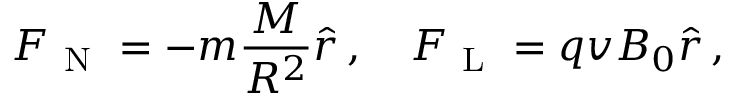Convert formula to latex. <formula><loc_0><loc_0><loc_500><loc_500>F _ { N } = - m \frac { M } { R ^ { 2 } } \hat { r } \, , \quad F _ { L } = q v B _ { 0 } \hat { r } \, ,</formula> 